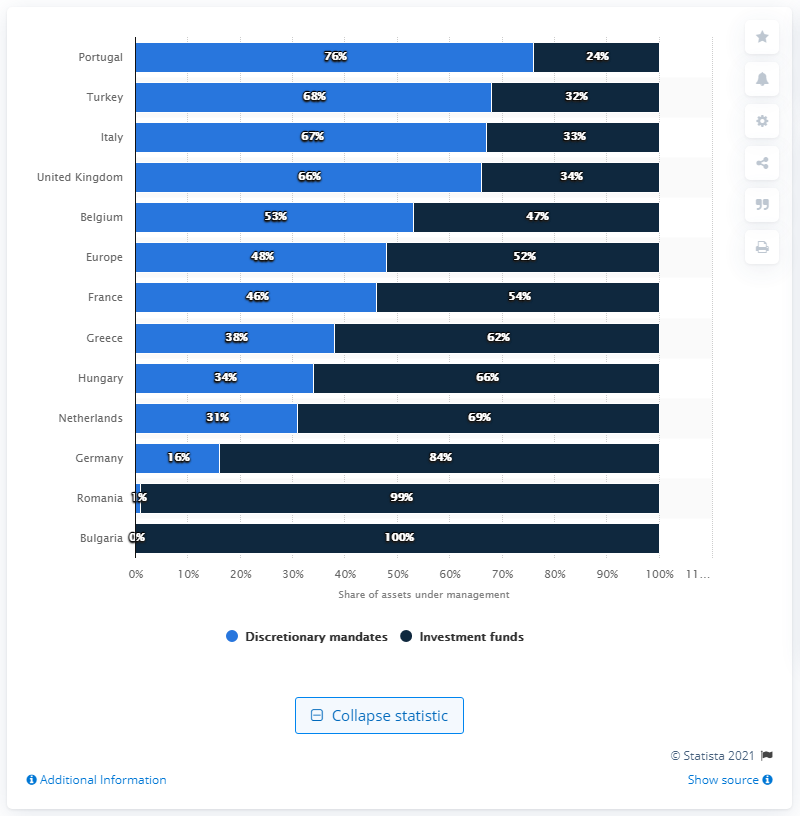Outline some significant characteristics in this image. As of 2020, discretionary mandate assets in the Netherlands accounted for approximately 31% of the market share. 